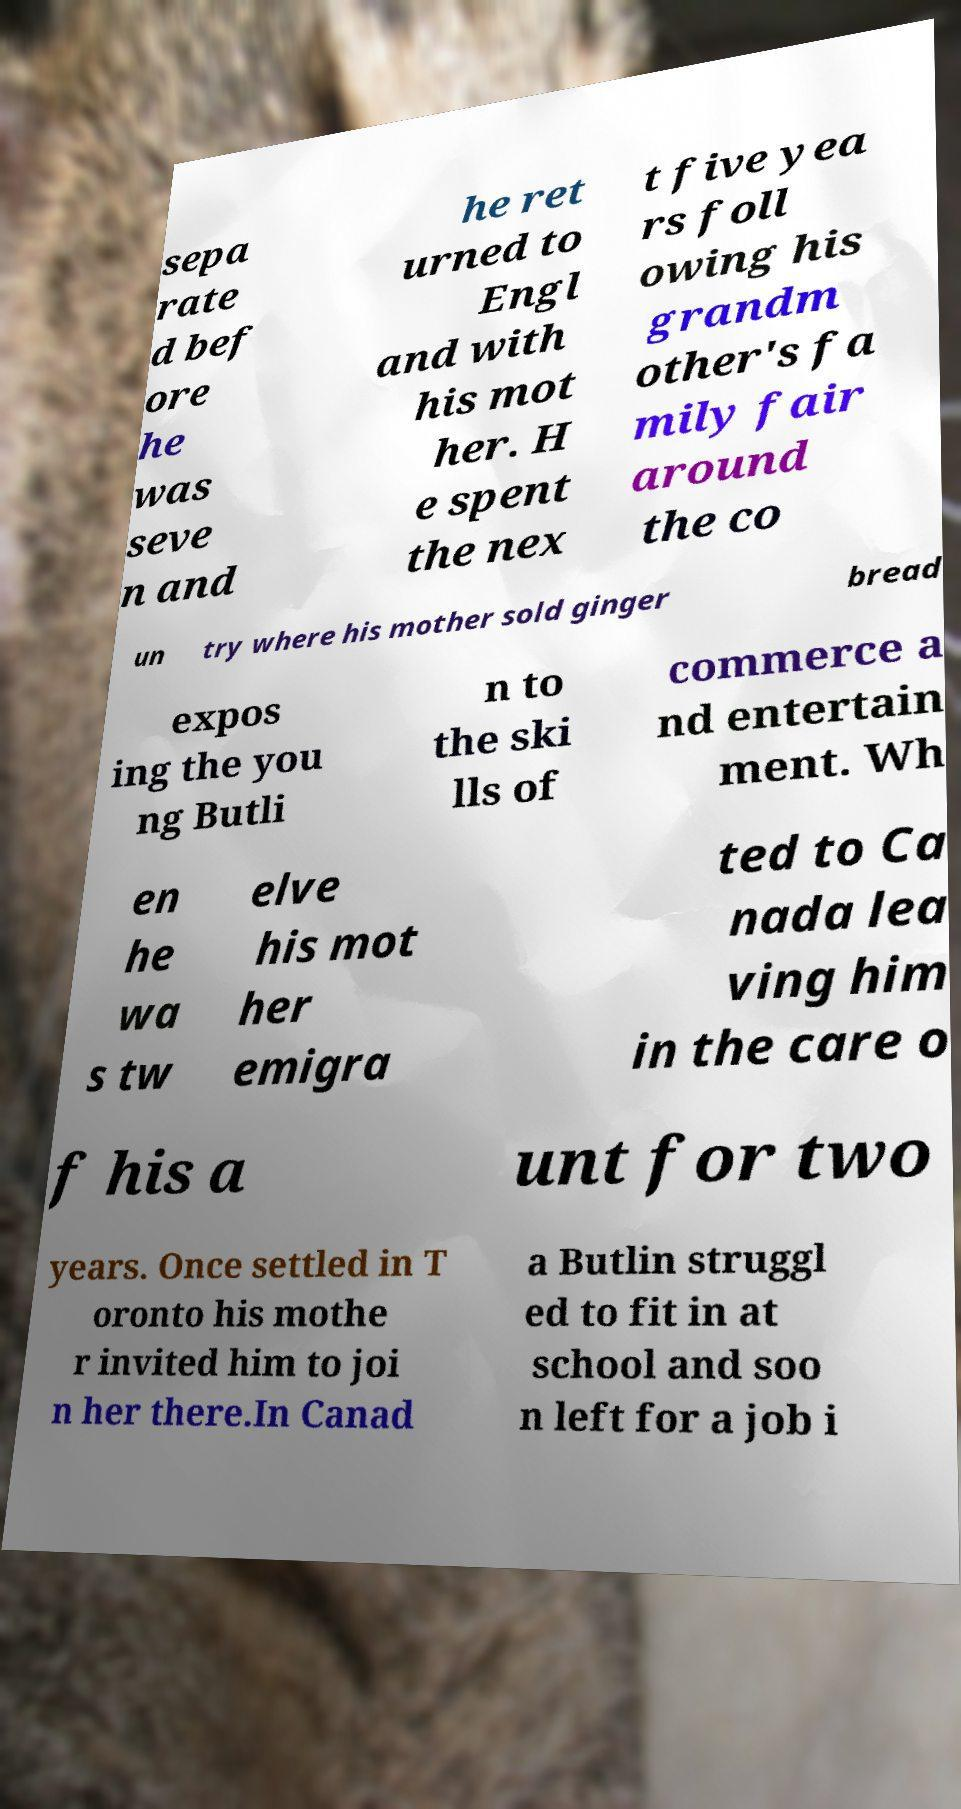What messages or text are displayed in this image? I need them in a readable, typed format. sepa rate d bef ore he was seve n and he ret urned to Engl and with his mot her. H e spent the nex t five yea rs foll owing his grandm other's fa mily fair around the co un try where his mother sold ginger bread expos ing the you ng Butli n to the ski lls of commerce a nd entertain ment. Wh en he wa s tw elve his mot her emigra ted to Ca nada lea ving him in the care o f his a unt for two years. Once settled in T oronto his mothe r invited him to joi n her there.In Canad a Butlin struggl ed to fit in at school and soo n left for a job i 